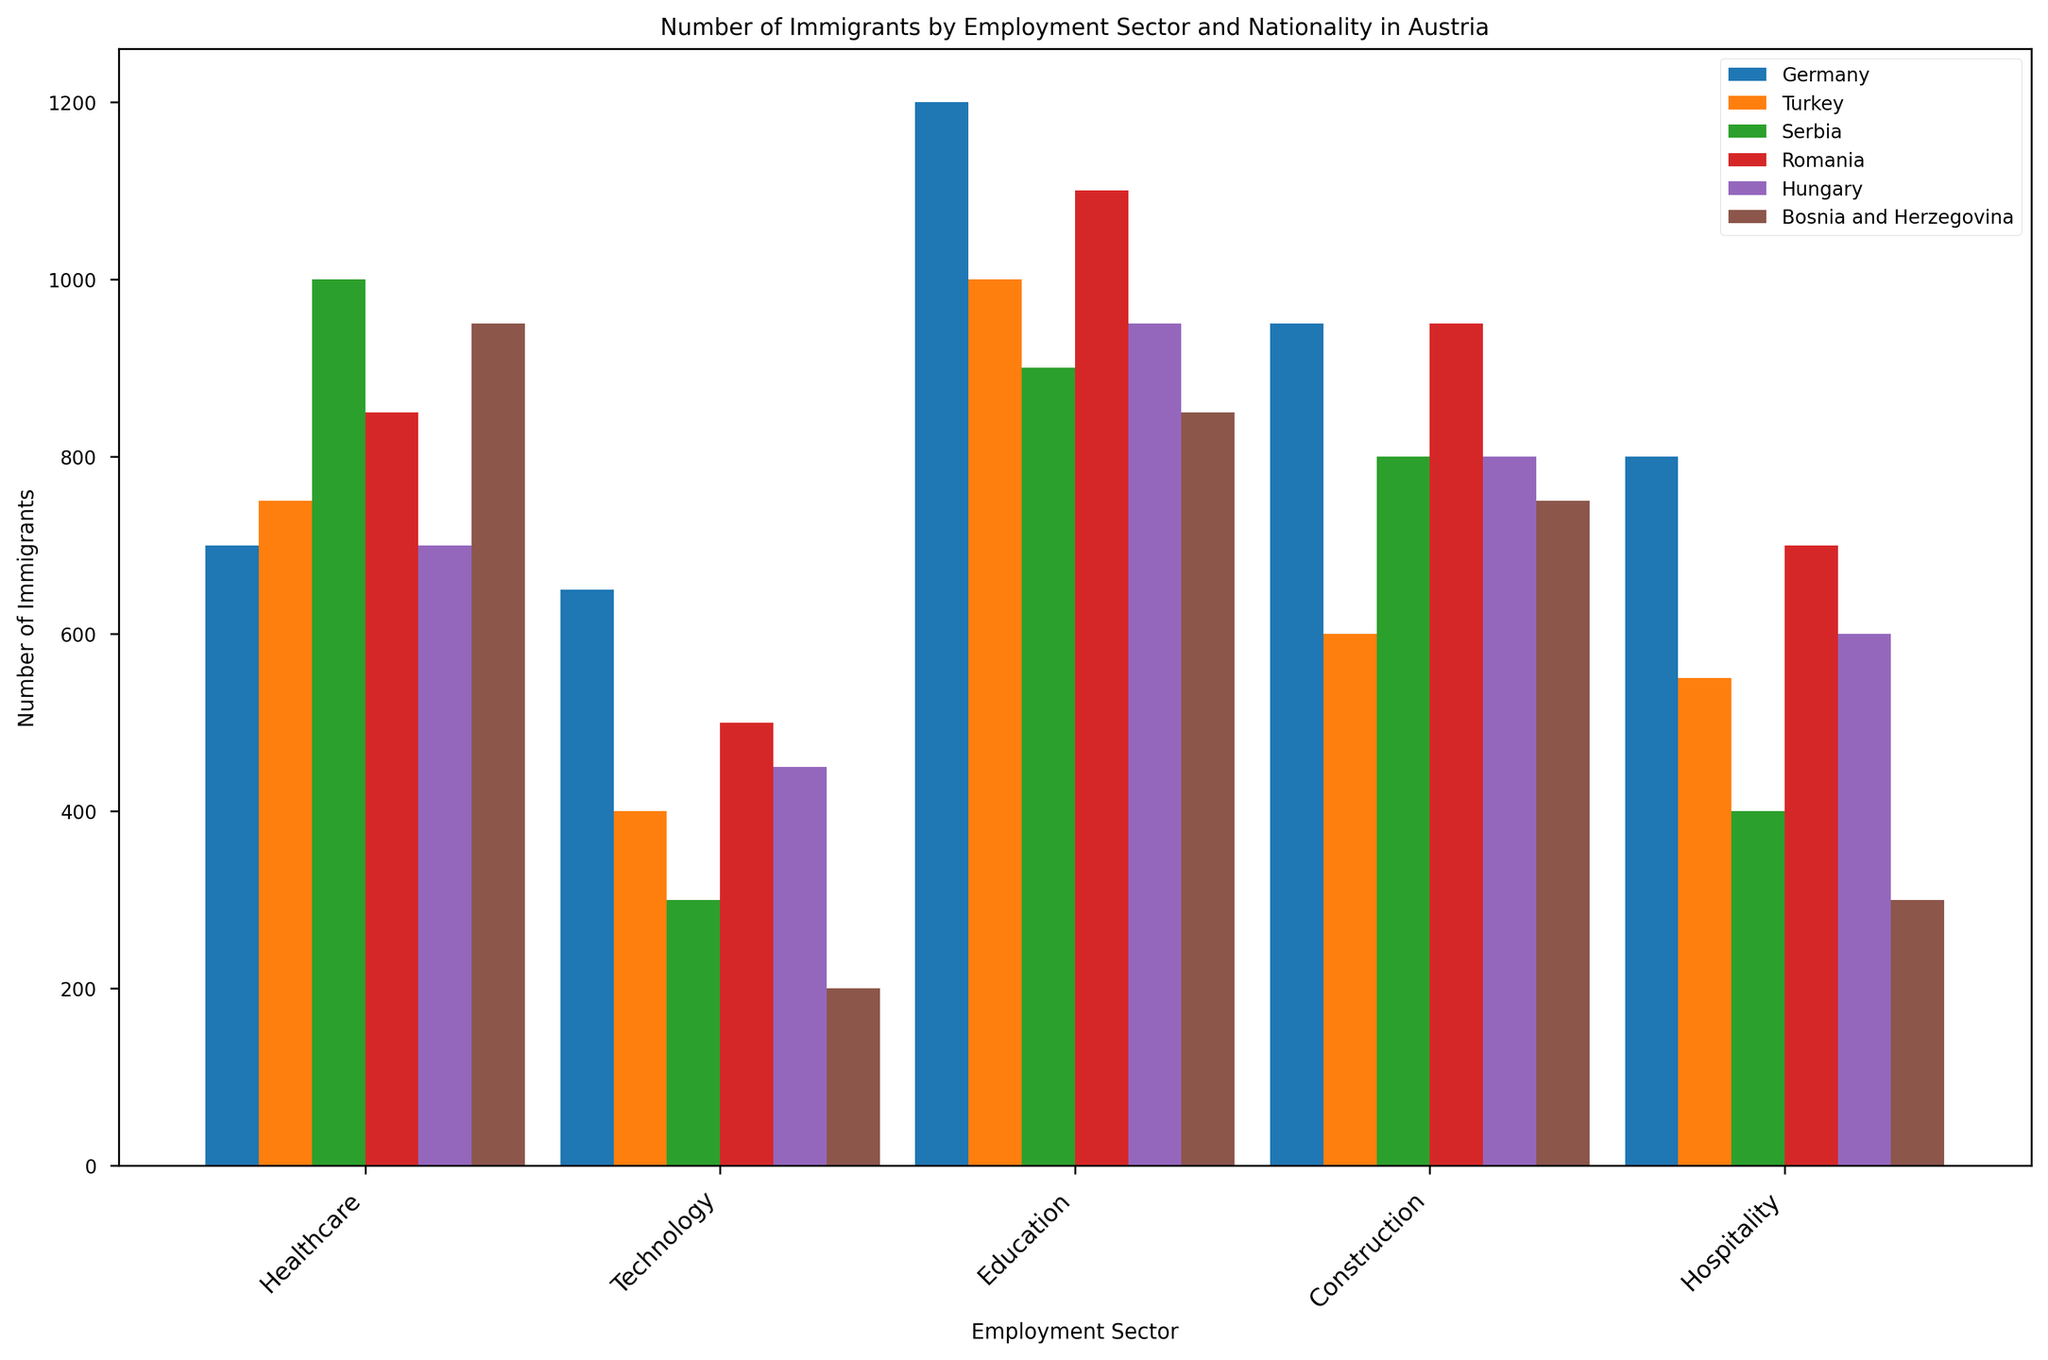Which nationality has the highest number of immigrants in the Healthcare sector? Look at the bars corresponding to the Healthcare sector and identify which one is the tallest. The tallest bar is for Germany with 1200 immigrants.
Answer: Germany Which sector has the least number of Serbian immigrants? Compare the heights of bars for Serbia across the different sectors. The Education sector has the lowest, with a height representing 300 immigrants.
Answer: Education Which sector employs more Turkish immigrants than German immigrants? Compare the bars for Turkey and Germany across all sectors. In the Healthcare sector, Turkish immigrants are more than German immigrants (1000 vs. 1200). In the Construction sector, Turkish immigrants are more than German immigrants (750 vs. 700).
Answer: Construction What is the total number of immigrants from Romania in the Technology and Healthcare sectors combined? Sum the heights of the bars for Romania in the Technology and Healthcare sectors. The sum is 700 (Technology) + 1100 (Healthcare) = 1800.
Answer: 1800 How does the number of Hungarian immigrants in Technology compare to that in Construction? Look at the heights of the bars for Hungary in Technology and Construction sectors. There are 600 immigrants in Technology and 700 in Construction. The number in Technology is less than in Construction.
Answer: Less Which nationality has the most evenly distributed number of immigrants across all sectors? Observe the relative heights of the bars for each nationality. Bosnia and Herzegovina has more balanced bars across sectors compared to others.
Answer: Bosnia and Herzegovina What is the difference in the number of German and Romanian immigrants in the Hospitality sector? Subtract the bar height for Romania from that of Germany in the Hospitality sector. The difference is 950 (Germany) - 950 (Romania) = 0.
Answer: 0 In which sector are the total immigrants from all nationalities the highest? Sum the heights of bars for all nationalities in each sector and compare. The Construction sector has the highest total.
Answer: Construction Which sector has the greatest difference between the highest and lowest number of immigrants? Look at the range of bar heights in each sector and calculate the difference. The Education sector has the greatest difference with 650 (Germany) and 200 (Bosnia and Herzegovina), difference is 450.
Answer: Education What is the average number of immigrants in the Hospitality sector across all nationalities? Sum the number of immigrants in the Hospitality sector for all nationalities and divide by the number of nationalities. Sum is 950 (Germany) + 600 (Turkey) + 800 (Serbia) + 950 (Romania) + 800 (Hungary) + 750 (Bosnia and Herzegovina) = 4850. The average is 4850 / 6 = 808.33.
Answer: 808.33 